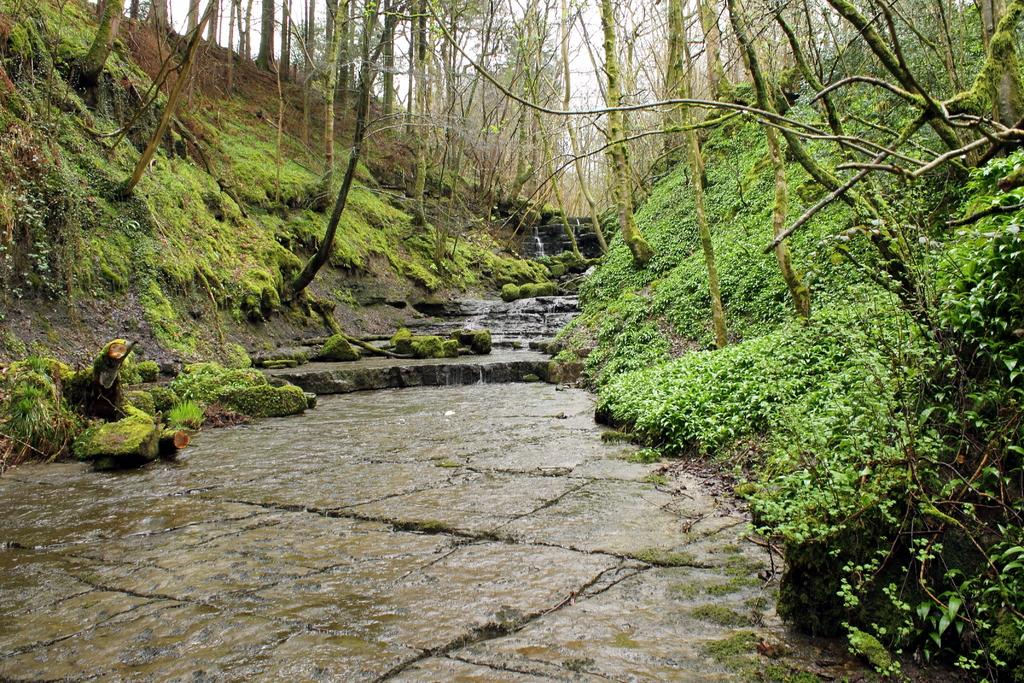What type of living organisms can be seen in the image? Plants and trees are visible in the image. What color are the plants and trees in the image? The plants and trees are green in color. What is visible in the background of the image? The sky is visible in the background of the image. What color is the sky in the image? The sky is white in color. What type of breakfast is being served on the volleyball in the image? There is no volleyball or breakfast present in the image; it features plants, trees, and a white sky. Can you see any worms crawling on the plants in the image? There are no worms visible on the plants in the image. 